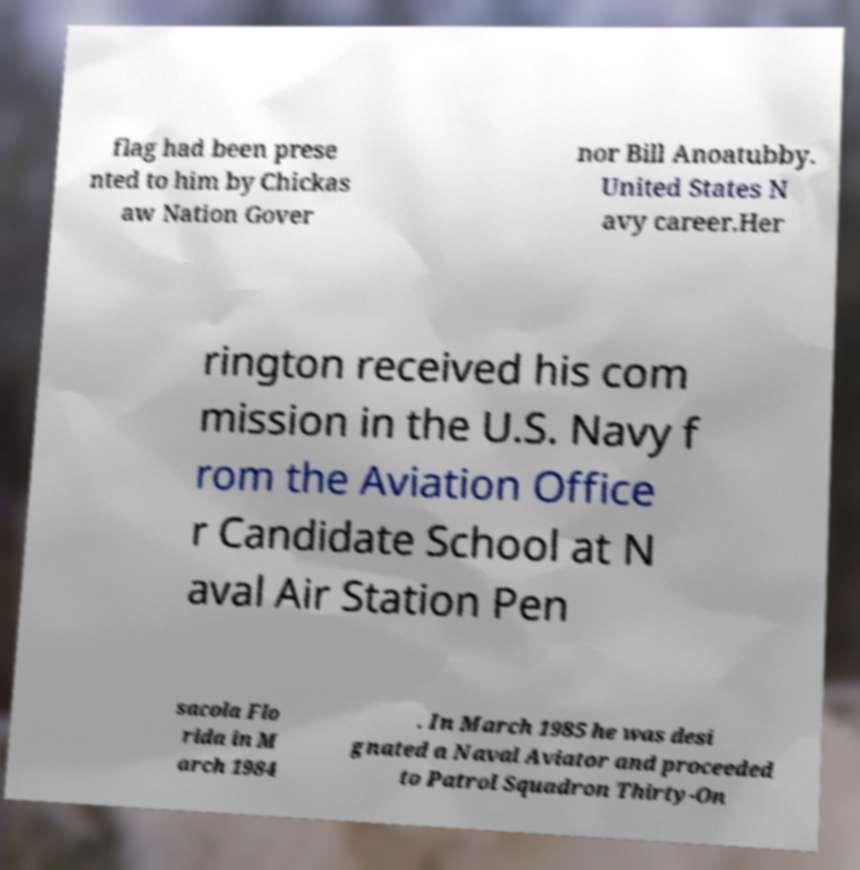I need the written content from this picture converted into text. Can you do that? flag had been prese nted to him by Chickas aw Nation Gover nor Bill Anoatubby. United States N avy career.Her rington received his com mission in the U.S. Navy f rom the Aviation Office r Candidate School at N aval Air Station Pen sacola Flo rida in M arch 1984 . In March 1985 he was desi gnated a Naval Aviator and proceeded to Patrol Squadron Thirty-On 